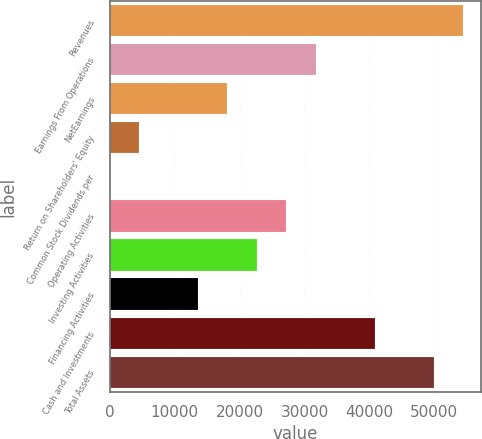Convert chart. <chart><loc_0><loc_0><loc_500><loc_500><bar_chart><fcel>Revenues<fcel>Earnings From Operations<fcel>NetEarnings<fcel>Return on Shareholders' Equity<fcel>Common Stock Dividends per<fcel>Operating Activities<fcel>Investing Activities<fcel>Financing Activities<fcel>Cash and Investments<fcel>Total Assets<nl><fcel>54438<fcel>31755.5<fcel>18146<fcel>4536.51<fcel>0.01<fcel>27219<fcel>22682.5<fcel>13609.5<fcel>40828.5<fcel>49901.5<nl></chart> 